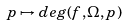Convert formula to latex. <formula><loc_0><loc_0><loc_500><loc_500>p \mapsto d e g ( f , \Omega , p )</formula> 